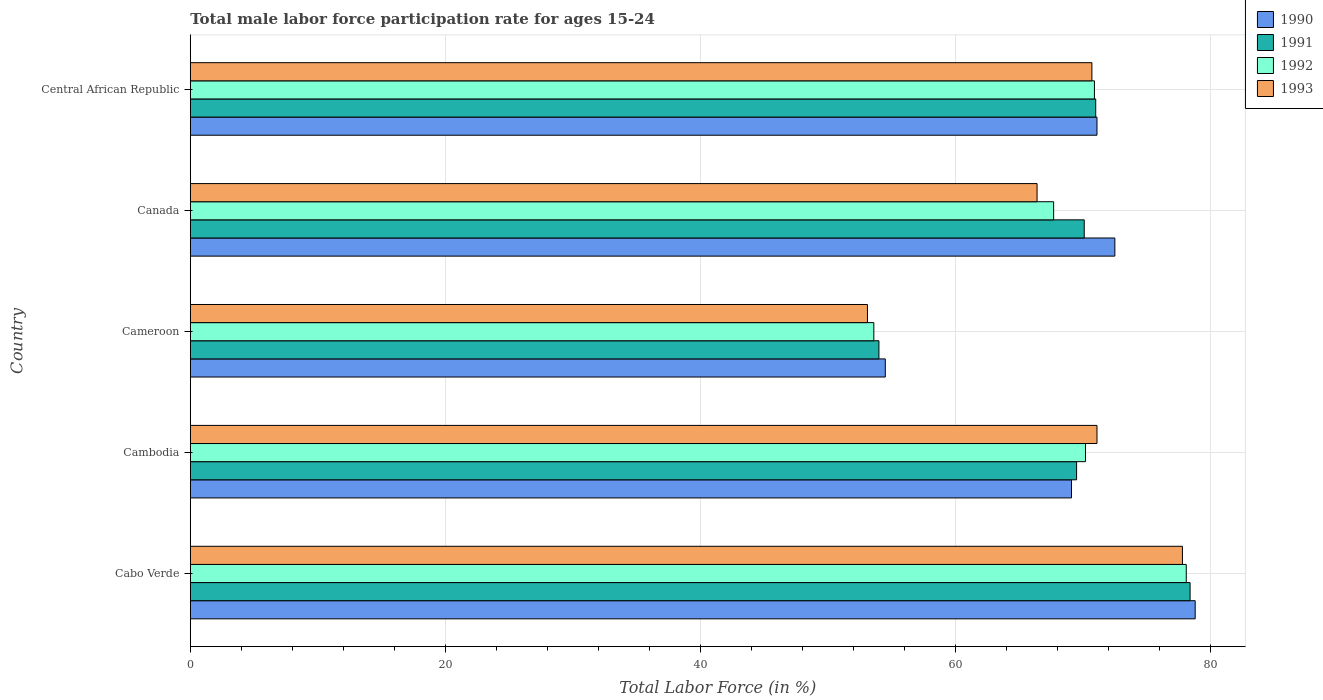How many groups of bars are there?
Provide a short and direct response. 5. Are the number of bars per tick equal to the number of legend labels?
Make the answer very short. Yes. How many bars are there on the 3rd tick from the top?
Your response must be concise. 4. How many bars are there on the 2nd tick from the bottom?
Provide a succinct answer. 4. What is the label of the 4th group of bars from the top?
Give a very brief answer. Cambodia. What is the male labor force participation rate in 1992 in Central African Republic?
Ensure brevity in your answer.  70.9. Across all countries, what is the maximum male labor force participation rate in 1992?
Offer a terse response. 78.1. Across all countries, what is the minimum male labor force participation rate in 1991?
Provide a short and direct response. 54. In which country was the male labor force participation rate in 1990 maximum?
Offer a terse response. Cabo Verde. In which country was the male labor force participation rate in 1992 minimum?
Provide a short and direct response. Cameroon. What is the total male labor force participation rate in 1992 in the graph?
Provide a short and direct response. 340.5. What is the difference between the male labor force participation rate in 1992 in Cabo Verde and that in Cameroon?
Make the answer very short. 24.5. What is the difference between the male labor force participation rate in 1993 in Cabo Verde and the male labor force participation rate in 1992 in Cambodia?
Your answer should be compact. 7.6. What is the average male labor force participation rate in 1991 per country?
Provide a short and direct response. 68.6. What is the difference between the male labor force participation rate in 1991 and male labor force participation rate in 1992 in Cambodia?
Your response must be concise. -0.7. What is the ratio of the male labor force participation rate in 1992 in Cambodia to that in Canada?
Make the answer very short. 1.04. Is the male labor force participation rate in 1993 in Cabo Verde less than that in Cambodia?
Offer a very short reply. No. Is the difference between the male labor force participation rate in 1991 in Cabo Verde and Cambodia greater than the difference between the male labor force participation rate in 1992 in Cabo Verde and Cambodia?
Provide a short and direct response. Yes. What is the difference between the highest and the second highest male labor force participation rate in 1991?
Keep it short and to the point. 7.4. What is the difference between the highest and the lowest male labor force participation rate in 1990?
Make the answer very short. 24.3. Is the sum of the male labor force participation rate in 1992 in Cameroon and Canada greater than the maximum male labor force participation rate in 1993 across all countries?
Offer a very short reply. Yes. Is it the case that in every country, the sum of the male labor force participation rate in 1991 and male labor force participation rate in 1992 is greater than the sum of male labor force participation rate in 1993 and male labor force participation rate in 1990?
Keep it short and to the point. No. What does the 2nd bar from the top in Canada represents?
Keep it short and to the point. 1992. What does the 2nd bar from the bottom in Cambodia represents?
Keep it short and to the point. 1991. Is it the case that in every country, the sum of the male labor force participation rate in 1990 and male labor force participation rate in 1991 is greater than the male labor force participation rate in 1992?
Provide a succinct answer. Yes. How many bars are there?
Your answer should be compact. 20. Are all the bars in the graph horizontal?
Your answer should be compact. Yes. How many countries are there in the graph?
Offer a very short reply. 5. What is the difference between two consecutive major ticks on the X-axis?
Ensure brevity in your answer.  20. Are the values on the major ticks of X-axis written in scientific E-notation?
Offer a terse response. No. Does the graph contain grids?
Offer a terse response. Yes. How many legend labels are there?
Ensure brevity in your answer.  4. What is the title of the graph?
Give a very brief answer. Total male labor force participation rate for ages 15-24. Does "1969" appear as one of the legend labels in the graph?
Offer a very short reply. No. What is the label or title of the X-axis?
Your response must be concise. Total Labor Force (in %). What is the Total Labor Force (in %) of 1990 in Cabo Verde?
Offer a terse response. 78.8. What is the Total Labor Force (in %) of 1991 in Cabo Verde?
Give a very brief answer. 78.4. What is the Total Labor Force (in %) in 1992 in Cabo Verde?
Your answer should be very brief. 78.1. What is the Total Labor Force (in %) in 1993 in Cabo Verde?
Provide a succinct answer. 77.8. What is the Total Labor Force (in %) in 1990 in Cambodia?
Offer a very short reply. 69.1. What is the Total Labor Force (in %) in 1991 in Cambodia?
Provide a short and direct response. 69.5. What is the Total Labor Force (in %) in 1992 in Cambodia?
Your response must be concise. 70.2. What is the Total Labor Force (in %) of 1993 in Cambodia?
Offer a very short reply. 71.1. What is the Total Labor Force (in %) of 1990 in Cameroon?
Offer a very short reply. 54.5. What is the Total Labor Force (in %) in 1992 in Cameroon?
Offer a very short reply. 53.6. What is the Total Labor Force (in %) in 1993 in Cameroon?
Your response must be concise. 53.1. What is the Total Labor Force (in %) in 1990 in Canada?
Provide a succinct answer. 72.5. What is the Total Labor Force (in %) of 1991 in Canada?
Keep it short and to the point. 70.1. What is the Total Labor Force (in %) of 1992 in Canada?
Ensure brevity in your answer.  67.7. What is the Total Labor Force (in %) of 1993 in Canada?
Provide a succinct answer. 66.4. What is the Total Labor Force (in %) of 1990 in Central African Republic?
Ensure brevity in your answer.  71.1. What is the Total Labor Force (in %) of 1991 in Central African Republic?
Make the answer very short. 71. What is the Total Labor Force (in %) of 1992 in Central African Republic?
Keep it short and to the point. 70.9. What is the Total Labor Force (in %) in 1993 in Central African Republic?
Provide a short and direct response. 70.7. Across all countries, what is the maximum Total Labor Force (in %) of 1990?
Your answer should be very brief. 78.8. Across all countries, what is the maximum Total Labor Force (in %) of 1991?
Offer a terse response. 78.4. Across all countries, what is the maximum Total Labor Force (in %) of 1992?
Give a very brief answer. 78.1. Across all countries, what is the maximum Total Labor Force (in %) of 1993?
Ensure brevity in your answer.  77.8. Across all countries, what is the minimum Total Labor Force (in %) in 1990?
Offer a terse response. 54.5. Across all countries, what is the minimum Total Labor Force (in %) in 1992?
Your response must be concise. 53.6. Across all countries, what is the minimum Total Labor Force (in %) of 1993?
Your response must be concise. 53.1. What is the total Total Labor Force (in %) of 1990 in the graph?
Offer a terse response. 346. What is the total Total Labor Force (in %) in 1991 in the graph?
Your answer should be very brief. 343. What is the total Total Labor Force (in %) in 1992 in the graph?
Your response must be concise. 340.5. What is the total Total Labor Force (in %) in 1993 in the graph?
Give a very brief answer. 339.1. What is the difference between the Total Labor Force (in %) of 1990 in Cabo Verde and that in Cambodia?
Your answer should be compact. 9.7. What is the difference between the Total Labor Force (in %) of 1992 in Cabo Verde and that in Cambodia?
Give a very brief answer. 7.9. What is the difference between the Total Labor Force (in %) in 1993 in Cabo Verde and that in Cambodia?
Make the answer very short. 6.7. What is the difference between the Total Labor Force (in %) in 1990 in Cabo Verde and that in Cameroon?
Your answer should be compact. 24.3. What is the difference between the Total Labor Force (in %) in 1991 in Cabo Verde and that in Cameroon?
Make the answer very short. 24.4. What is the difference between the Total Labor Force (in %) of 1992 in Cabo Verde and that in Cameroon?
Your answer should be compact. 24.5. What is the difference between the Total Labor Force (in %) in 1993 in Cabo Verde and that in Cameroon?
Offer a very short reply. 24.7. What is the difference between the Total Labor Force (in %) in 1992 in Cabo Verde and that in Canada?
Your answer should be compact. 10.4. What is the difference between the Total Labor Force (in %) of 1993 in Cabo Verde and that in Canada?
Offer a terse response. 11.4. What is the difference between the Total Labor Force (in %) in 1991 in Cambodia and that in Cameroon?
Keep it short and to the point. 15.5. What is the difference between the Total Labor Force (in %) in 1992 in Cambodia and that in Cameroon?
Your answer should be compact. 16.6. What is the difference between the Total Labor Force (in %) of 1991 in Cambodia and that in Canada?
Offer a very short reply. -0.6. What is the difference between the Total Labor Force (in %) of 1993 in Cambodia and that in Canada?
Provide a succinct answer. 4.7. What is the difference between the Total Labor Force (in %) of 1990 in Cambodia and that in Central African Republic?
Ensure brevity in your answer.  -2. What is the difference between the Total Labor Force (in %) of 1992 in Cambodia and that in Central African Republic?
Your answer should be compact. -0.7. What is the difference between the Total Labor Force (in %) of 1990 in Cameroon and that in Canada?
Give a very brief answer. -18. What is the difference between the Total Labor Force (in %) in 1991 in Cameroon and that in Canada?
Your answer should be very brief. -16.1. What is the difference between the Total Labor Force (in %) of 1992 in Cameroon and that in Canada?
Provide a succinct answer. -14.1. What is the difference between the Total Labor Force (in %) in 1993 in Cameroon and that in Canada?
Keep it short and to the point. -13.3. What is the difference between the Total Labor Force (in %) in 1990 in Cameroon and that in Central African Republic?
Ensure brevity in your answer.  -16.6. What is the difference between the Total Labor Force (in %) in 1991 in Cameroon and that in Central African Republic?
Ensure brevity in your answer.  -17. What is the difference between the Total Labor Force (in %) of 1992 in Cameroon and that in Central African Republic?
Make the answer very short. -17.3. What is the difference between the Total Labor Force (in %) in 1993 in Cameroon and that in Central African Republic?
Your response must be concise. -17.6. What is the difference between the Total Labor Force (in %) of 1991 in Canada and that in Central African Republic?
Your answer should be compact. -0.9. What is the difference between the Total Labor Force (in %) of 1992 in Canada and that in Central African Republic?
Make the answer very short. -3.2. What is the difference between the Total Labor Force (in %) of 1993 in Canada and that in Central African Republic?
Your answer should be compact. -4.3. What is the difference between the Total Labor Force (in %) of 1990 in Cabo Verde and the Total Labor Force (in %) of 1991 in Cambodia?
Keep it short and to the point. 9.3. What is the difference between the Total Labor Force (in %) in 1990 in Cabo Verde and the Total Labor Force (in %) in 1992 in Cambodia?
Your response must be concise. 8.6. What is the difference between the Total Labor Force (in %) of 1991 in Cabo Verde and the Total Labor Force (in %) of 1992 in Cambodia?
Provide a succinct answer. 8.2. What is the difference between the Total Labor Force (in %) in 1991 in Cabo Verde and the Total Labor Force (in %) in 1993 in Cambodia?
Make the answer very short. 7.3. What is the difference between the Total Labor Force (in %) in 1992 in Cabo Verde and the Total Labor Force (in %) in 1993 in Cambodia?
Offer a terse response. 7. What is the difference between the Total Labor Force (in %) of 1990 in Cabo Verde and the Total Labor Force (in %) of 1991 in Cameroon?
Provide a succinct answer. 24.8. What is the difference between the Total Labor Force (in %) of 1990 in Cabo Verde and the Total Labor Force (in %) of 1992 in Cameroon?
Provide a succinct answer. 25.2. What is the difference between the Total Labor Force (in %) of 1990 in Cabo Verde and the Total Labor Force (in %) of 1993 in Cameroon?
Provide a succinct answer. 25.7. What is the difference between the Total Labor Force (in %) in 1991 in Cabo Verde and the Total Labor Force (in %) in 1992 in Cameroon?
Provide a short and direct response. 24.8. What is the difference between the Total Labor Force (in %) in 1991 in Cabo Verde and the Total Labor Force (in %) in 1993 in Cameroon?
Offer a terse response. 25.3. What is the difference between the Total Labor Force (in %) in 1992 in Cabo Verde and the Total Labor Force (in %) in 1993 in Cameroon?
Provide a succinct answer. 25. What is the difference between the Total Labor Force (in %) in 1990 in Cabo Verde and the Total Labor Force (in %) in 1991 in Canada?
Provide a short and direct response. 8.7. What is the difference between the Total Labor Force (in %) of 1990 in Cabo Verde and the Total Labor Force (in %) of 1992 in Canada?
Keep it short and to the point. 11.1. What is the difference between the Total Labor Force (in %) of 1990 in Cabo Verde and the Total Labor Force (in %) of 1993 in Canada?
Your answer should be compact. 12.4. What is the difference between the Total Labor Force (in %) in 1991 in Cabo Verde and the Total Labor Force (in %) in 1992 in Canada?
Provide a short and direct response. 10.7. What is the difference between the Total Labor Force (in %) in 1992 in Cabo Verde and the Total Labor Force (in %) in 1993 in Canada?
Provide a short and direct response. 11.7. What is the difference between the Total Labor Force (in %) of 1990 in Cabo Verde and the Total Labor Force (in %) of 1991 in Central African Republic?
Provide a succinct answer. 7.8. What is the difference between the Total Labor Force (in %) of 1990 in Cabo Verde and the Total Labor Force (in %) of 1992 in Central African Republic?
Provide a short and direct response. 7.9. What is the difference between the Total Labor Force (in %) of 1991 in Cabo Verde and the Total Labor Force (in %) of 1992 in Central African Republic?
Your answer should be very brief. 7.5. What is the difference between the Total Labor Force (in %) of 1991 in Cabo Verde and the Total Labor Force (in %) of 1993 in Central African Republic?
Make the answer very short. 7.7. What is the difference between the Total Labor Force (in %) in 1990 in Cambodia and the Total Labor Force (in %) in 1991 in Cameroon?
Your response must be concise. 15.1. What is the difference between the Total Labor Force (in %) in 1991 in Cambodia and the Total Labor Force (in %) in 1992 in Cameroon?
Keep it short and to the point. 15.9. What is the difference between the Total Labor Force (in %) in 1991 in Cambodia and the Total Labor Force (in %) in 1993 in Cameroon?
Your answer should be very brief. 16.4. What is the difference between the Total Labor Force (in %) in 1992 in Cambodia and the Total Labor Force (in %) in 1993 in Cameroon?
Your answer should be compact. 17.1. What is the difference between the Total Labor Force (in %) in 1990 in Cambodia and the Total Labor Force (in %) in 1991 in Canada?
Offer a terse response. -1. What is the difference between the Total Labor Force (in %) in 1990 in Cambodia and the Total Labor Force (in %) in 1993 in Canada?
Make the answer very short. 2.7. What is the difference between the Total Labor Force (in %) in 1991 in Cambodia and the Total Labor Force (in %) in 1992 in Canada?
Give a very brief answer. 1.8. What is the difference between the Total Labor Force (in %) of 1991 in Cambodia and the Total Labor Force (in %) of 1993 in Canada?
Provide a succinct answer. 3.1. What is the difference between the Total Labor Force (in %) of 1992 in Cambodia and the Total Labor Force (in %) of 1993 in Canada?
Give a very brief answer. 3.8. What is the difference between the Total Labor Force (in %) in 1990 in Cambodia and the Total Labor Force (in %) in 1991 in Central African Republic?
Ensure brevity in your answer.  -1.9. What is the difference between the Total Labor Force (in %) in 1990 in Cambodia and the Total Labor Force (in %) in 1992 in Central African Republic?
Give a very brief answer. -1.8. What is the difference between the Total Labor Force (in %) in 1990 in Cambodia and the Total Labor Force (in %) in 1993 in Central African Republic?
Your response must be concise. -1.6. What is the difference between the Total Labor Force (in %) of 1990 in Cameroon and the Total Labor Force (in %) of 1991 in Canada?
Offer a very short reply. -15.6. What is the difference between the Total Labor Force (in %) in 1990 in Cameroon and the Total Labor Force (in %) in 1993 in Canada?
Provide a short and direct response. -11.9. What is the difference between the Total Labor Force (in %) in 1991 in Cameroon and the Total Labor Force (in %) in 1992 in Canada?
Keep it short and to the point. -13.7. What is the difference between the Total Labor Force (in %) of 1992 in Cameroon and the Total Labor Force (in %) of 1993 in Canada?
Your response must be concise. -12.8. What is the difference between the Total Labor Force (in %) in 1990 in Cameroon and the Total Labor Force (in %) in 1991 in Central African Republic?
Your answer should be compact. -16.5. What is the difference between the Total Labor Force (in %) in 1990 in Cameroon and the Total Labor Force (in %) in 1992 in Central African Republic?
Provide a short and direct response. -16.4. What is the difference between the Total Labor Force (in %) in 1990 in Cameroon and the Total Labor Force (in %) in 1993 in Central African Republic?
Your answer should be compact. -16.2. What is the difference between the Total Labor Force (in %) in 1991 in Cameroon and the Total Labor Force (in %) in 1992 in Central African Republic?
Keep it short and to the point. -16.9. What is the difference between the Total Labor Force (in %) in 1991 in Cameroon and the Total Labor Force (in %) in 1993 in Central African Republic?
Ensure brevity in your answer.  -16.7. What is the difference between the Total Labor Force (in %) of 1992 in Cameroon and the Total Labor Force (in %) of 1993 in Central African Republic?
Your response must be concise. -17.1. What is the difference between the Total Labor Force (in %) in 1991 in Canada and the Total Labor Force (in %) in 1993 in Central African Republic?
Your response must be concise. -0.6. What is the average Total Labor Force (in %) in 1990 per country?
Ensure brevity in your answer.  69.2. What is the average Total Labor Force (in %) of 1991 per country?
Offer a very short reply. 68.6. What is the average Total Labor Force (in %) in 1992 per country?
Your response must be concise. 68.1. What is the average Total Labor Force (in %) of 1993 per country?
Ensure brevity in your answer.  67.82. What is the difference between the Total Labor Force (in %) in 1990 and Total Labor Force (in %) in 1992 in Cabo Verde?
Provide a succinct answer. 0.7. What is the difference between the Total Labor Force (in %) in 1990 and Total Labor Force (in %) in 1993 in Cabo Verde?
Provide a short and direct response. 1. What is the difference between the Total Labor Force (in %) of 1991 and Total Labor Force (in %) of 1993 in Cabo Verde?
Provide a short and direct response. 0.6. What is the difference between the Total Labor Force (in %) of 1992 and Total Labor Force (in %) of 1993 in Cabo Verde?
Your response must be concise. 0.3. What is the difference between the Total Labor Force (in %) of 1990 and Total Labor Force (in %) of 1991 in Cambodia?
Provide a succinct answer. -0.4. What is the difference between the Total Labor Force (in %) of 1991 and Total Labor Force (in %) of 1993 in Cambodia?
Give a very brief answer. -1.6. What is the difference between the Total Labor Force (in %) in 1990 and Total Labor Force (in %) in 1993 in Cameroon?
Give a very brief answer. 1.4. What is the difference between the Total Labor Force (in %) of 1991 and Total Labor Force (in %) of 1992 in Cameroon?
Provide a succinct answer. 0.4. What is the difference between the Total Labor Force (in %) of 1991 and Total Labor Force (in %) of 1993 in Cameroon?
Keep it short and to the point. 0.9. What is the difference between the Total Labor Force (in %) of 1990 and Total Labor Force (in %) of 1991 in Canada?
Offer a very short reply. 2.4. What is the difference between the Total Labor Force (in %) in 1990 and Total Labor Force (in %) in 1992 in Canada?
Give a very brief answer. 4.8. What is the difference between the Total Labor Force (in %) of 1991 and Total Labor Force (in %) of 1992 in Canada?
Offer a terse response. 2.4. What is the difference between the Total Labor Force (in %) of 1990 and Total Labor Force (in %) of 1991 in Central African Republic?
Make the answer very short. 0.1. What is the difference between the Total Labor Force (in %) of 1990 and Total Labor Force (in %) of 1992 in Central African Republic?
Provide a succinct answer. 0.2. What is the difference between the Total Labor Force (in %) of 1990 and Total Labor Force (in %) of 1993 in Central African Republic?
Make the answer very short. 0.4. What is the difference between the Total Labor Force (in %) in 1991 and Total Labor Force (in %) in 1992 in Central African Republic?
Make the answer very short. 0.1. What is the ratio of the Total Labor Force (in %) of 1990 in Cabo Verde to that in Cambodia?
Your answer should be very brief. 1.14. What is the ratio of the Total Labor Force (in %) in 1991 in Cabo Verde to that in Cambodia?
Provide a short and direct response. 1.13. What is the ratio of the Total Labor Force (in %) in 1992 in Cabo Verde to that in Cambodia?
Provide a succinct answer. 1.11. What is the ratio of the Total Labor Force (in %) in 1993 in Cabo Verde to that in Cambodia?
Your answer should be compact. 1.09. What is the ratio of the Total Labor Force (in %) of 1990 in Cabo Verde to that in Cameroon?
Provide a succinct answer. 1.45. What is the ratio of the Total Labor Force (in %) of 1991 in Cabo Verde to that in Cameroon?
Offer a terse response. 1.45. What is the ratio of the Total Labor Force (in %) in 1992 in Cabo Verde to that in Cameroon?
Keep it short and to the point. 1.46. What is the ratio of the Total Labor Force (in %) in 1993 in Cabo Verde to that in Cameroon?
Provide a succinct answer. 1.47. What is the ratio of the Total Labor Force (in %) of 1990 in Cabo Verde to that in Canada?
Offer a very short reply. 1.09. What is the ratio of the Total Labor Force (in %) in 1991 in Cabo Verde to that in Canada?
Your answer should be very brief. 1.12. What is the ratio of the Total Labor Force (in %) of 1992 in Cabo Verde to that in Canada?
Provide a succinct answer. 1.15. What is the ratio of the Total Labor Force (in %) in 1993 in Cabo Verde to that in Canada?
Give a very brief answer. 1.17. What is the ratio of the Total Labor Force (in %) of 1990 in Cabo Verde to that in Central African Republic?
Your answer should be compact. 1.11. What is the ratio of the Total Labor Force (in %) in 1991 in Cabo Verde to that in Central African Republic?
Offer a very short reply. 1.1. What is the ratio of the Total Labor Force (in %) in 1992 in Cabo Verde to that in Central African Republic?
Give a very brief answer. 1.1. What is the ratio of the Total Labor Force (in %) in 1993 in Cabo Verde to that in Central African Republic?
Provide a short and direct response. 1.1. What is the ratio of the Total Labor Force (in %) in 1990 in Cambodia to that in Cameroon?
Give a very brief answer. 1.27. What is the ratio of the Total Labor Force (in %) of 1991 in Cambodia to that in Cameroon?
Make the answer very short. 1.29. What is the ratio of the Total Labor Force (in %) in 1992 in Cambodia to that in Cameroon?
Your answer should be very brief. 1.31. What is the ratio of the Total Labor Force (in %) in 1993 in Cambodia to that in Cameroon?
Keep it short and to the point. 1.34. What is the ratio of the Total Labor Force (in %) in 1990 in Cambodia to that in Canada?
Offer a terse response. 0.95. What is the ratio of the Total Labor Force (in %) of 1992 in Cambodia to that in Canada?
Keep it short and to the point. 1.04. What is the ratio of the Total Labor Force (in %) of 1993 in Cambodia to that in Canada?
Make the answer very short. 1.07. What is the ratio of the Total Labor Force (in %) of 1990 in Cambodia to that in Central African Republic?
Your response must be concise. 0.97. What is the ratio of the Total Labor Force (in %) of 1991 in Cambodia to that in Central African Republic?
Keep it short and to the point. 0.98. What is the ratio of the Total Labor Force (in %) of 1993 in Cambodia to that in Central African Republic?
Provide a short and direct response. 1.01. What is the ratio of the Total Labor Force (in %) of 1990 in Cameroon to that in Canada?
Offer a terse response. 0.75. What is the ratio of the Total Labor Force (in %) of 1991 in Cameroon to that in Canada?
Your answer should be compact. 0.77. What is the ratio of the Total Labor Force (in %) of 1992 in Cameroon to that in Canada?
Ensure brevity in your answer.  0.79. What is the ratio of the Total Labor Force (in %) of 1993 in Cameroon to that in Canada?
Give a very brief answer. 0.8. What is the ratio of the Total Labor Force (in %) of 1990 in Cameroon to that in Central African Republic?
Ensure brevity in your answer.  0.77. What is the ratio of the Total Labor Force (in %) of 1991 in Cameroon to that in Central African Republic?
Make the answer very short. 0.76. What is the ratio of the Total Labor Force (in %) of 1992 in Cameroon to that in Central African Republic?
Offer a terse response. 0.76. What is the ratio of the Total Labor Force (in %) in 1993 in Cameroon to that in Central African Republic?
Your answer should be very brief. 0.75. What is the ratio of the Total Labor Force (in %) of 1990 in Canada to that in Central African Republic?
Your response must be concise. 1.02. What is the ratio of the Total Labor Force (in %) of 1991 in Canada to that in Central African Republic?
Provide a succinct answer. 0.99. What is the ratio of the Total Labor Force (in %) in 1992 in Canada to that in Central African Republic?
Provide a succinct answer. 0.95. What is the ratio of the Total Labor Force (in %) of 1993 in Canada to that in Central African Republic?
Ensure brevity in your answer.  0.94. What is the difference between the highest and the second highest Total Labor Force (in %) of 1990?
Offer a terse response. 6.3. What is the difference between the highest and the second highest Total Labor Force (in %) of 1991?
Offer a very short reply. 7.4. What is the difference between the highest and the second highest Total Labor Force (in %) of 1992?
Your answer should be compact. 7.2. What is the difference between the highest and the lowest Total Labor Force (in %) in 1990?
Your answer should be very brief. 24.3. What is the difference between the highest and the lowest Total Labor Force (in %) of 1991?
Offer a terse response. 24.4. What is the difference between the highest and the lowest Total Labor Force (in %) in 1992?
Keep it short and to the point. 24.5. What is the difference between the highest and the lowest Total Labor Force (in %) in 1993?
Make the answer very short. 24.7. 